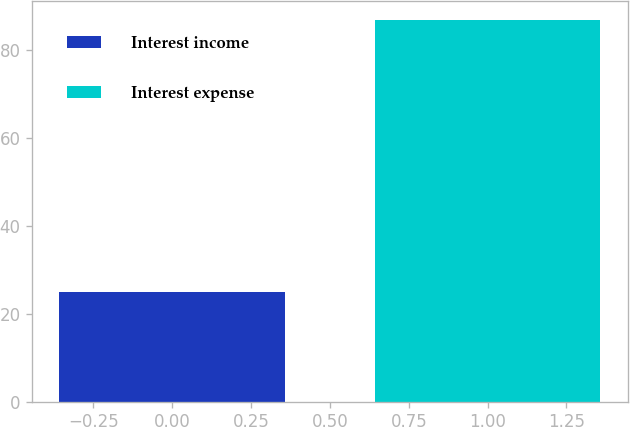<chart> <loc_0><loc_0><loc_500><loc_500><bar_chart><fcel>Interest income<fcel>Interest expense<nl><fcel>25<fcel>87<nl></chart> 